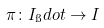Convert formula to latex. <formula><loc_0><loc_0><loc_500><loc_500>\pi \colon I _ { \i } d o t \to I</formula> 